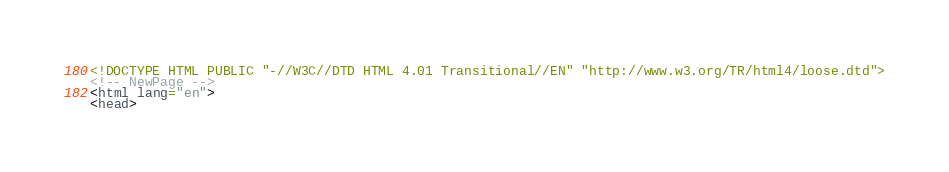<code> <loc_0><loc_0><loc_500><loc_500><_HTML_><!DOCTYPE HTML PUBLIC "-//W3C//DTD HTML 4.01 Transitional//EN" "http://www.w3.org/TR/html4/loose.dtd">
<!-- NewPage -->
<html lang="en">
<head></code> 